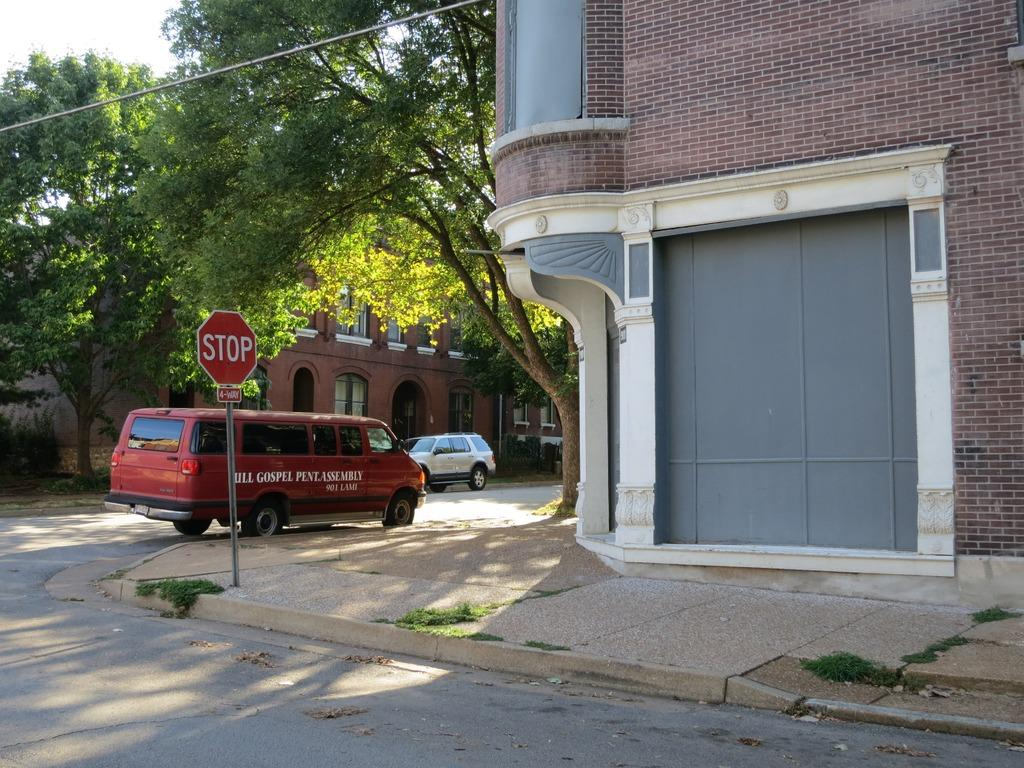What type of structure is present in the image? There is a building in the image. What feature can be observed on the building? The building has windows. What is happening on the road in the image? There are cars traveling on the road in the image. What is located near the road in the image? There is a sign board in the image. What type of natural elements are present in the image? There are many trees in the image. What is visible at the top of the image? The sky is visible at the top of the image. What is the tendency of the slaves in the image? There are no slaves present in the image. How much amount of water is visible in the image? There is no water visible in the image. 